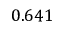<formula> <loc_0><loc_0><loc_500><loc_500>0 . 6 4 1</formula> 